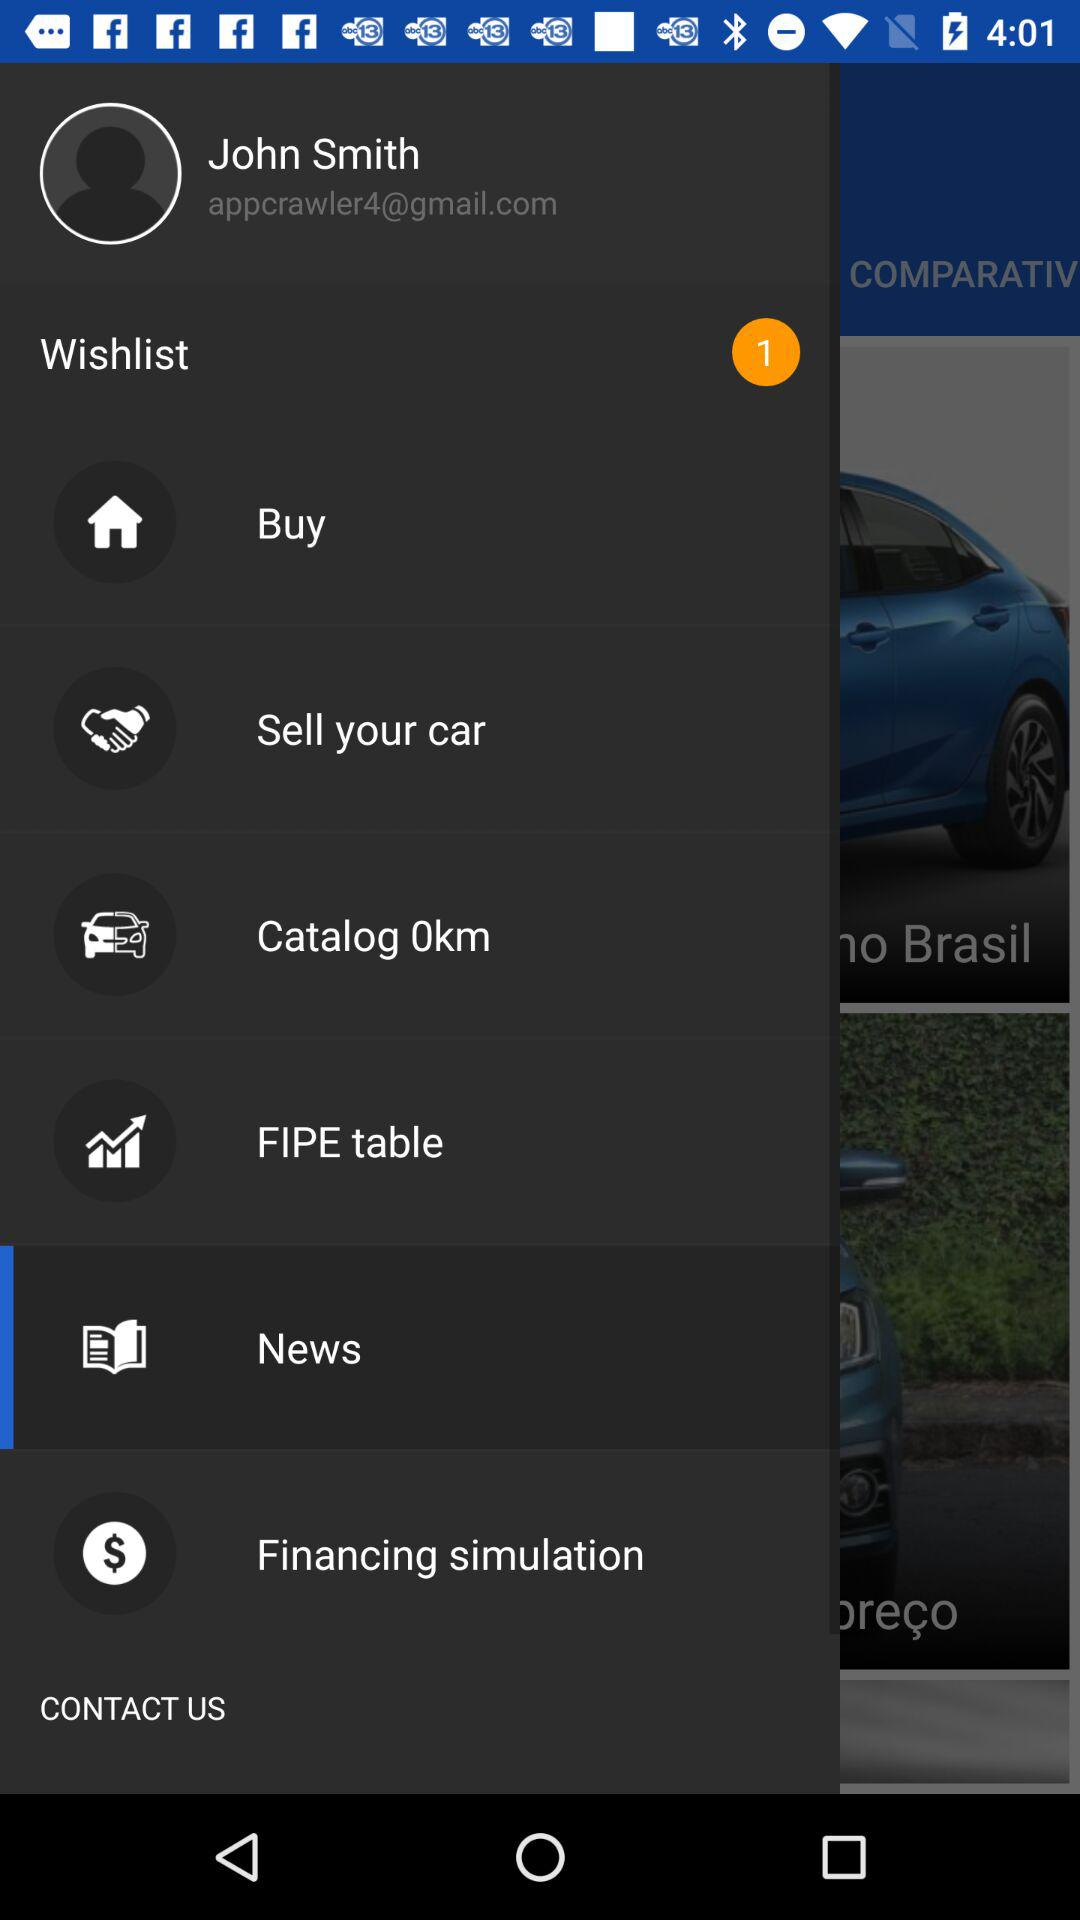How many items are there in the wishlist? There is 1 item in the wishlist. 